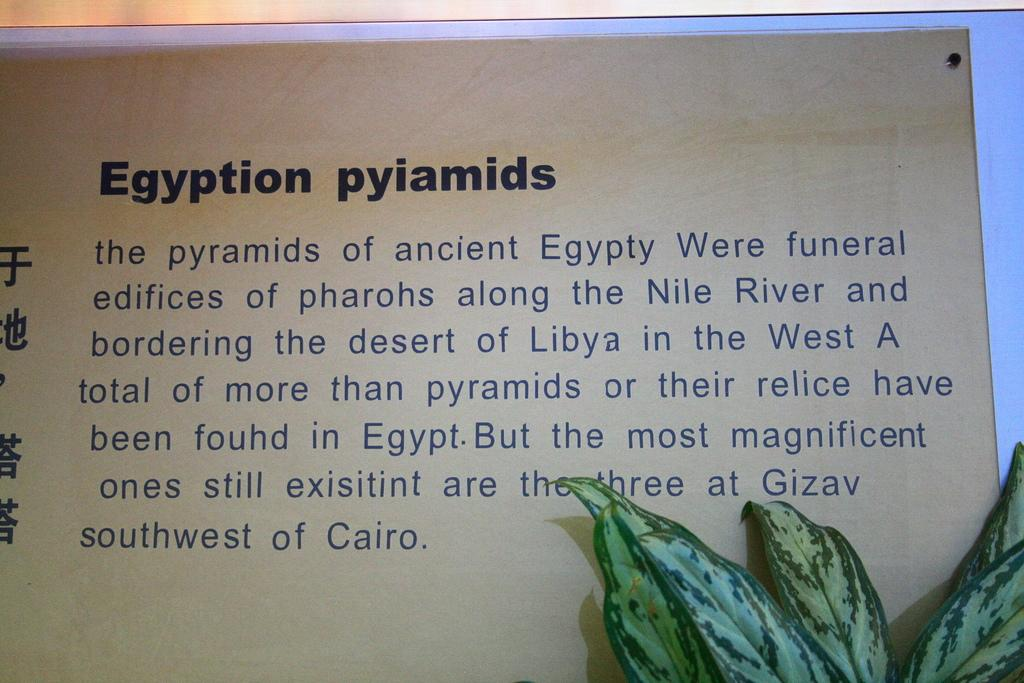<image>
Relay a brief, clear account of the picture shown. A text that explains about Egyption Pyiamids and where to find them. 